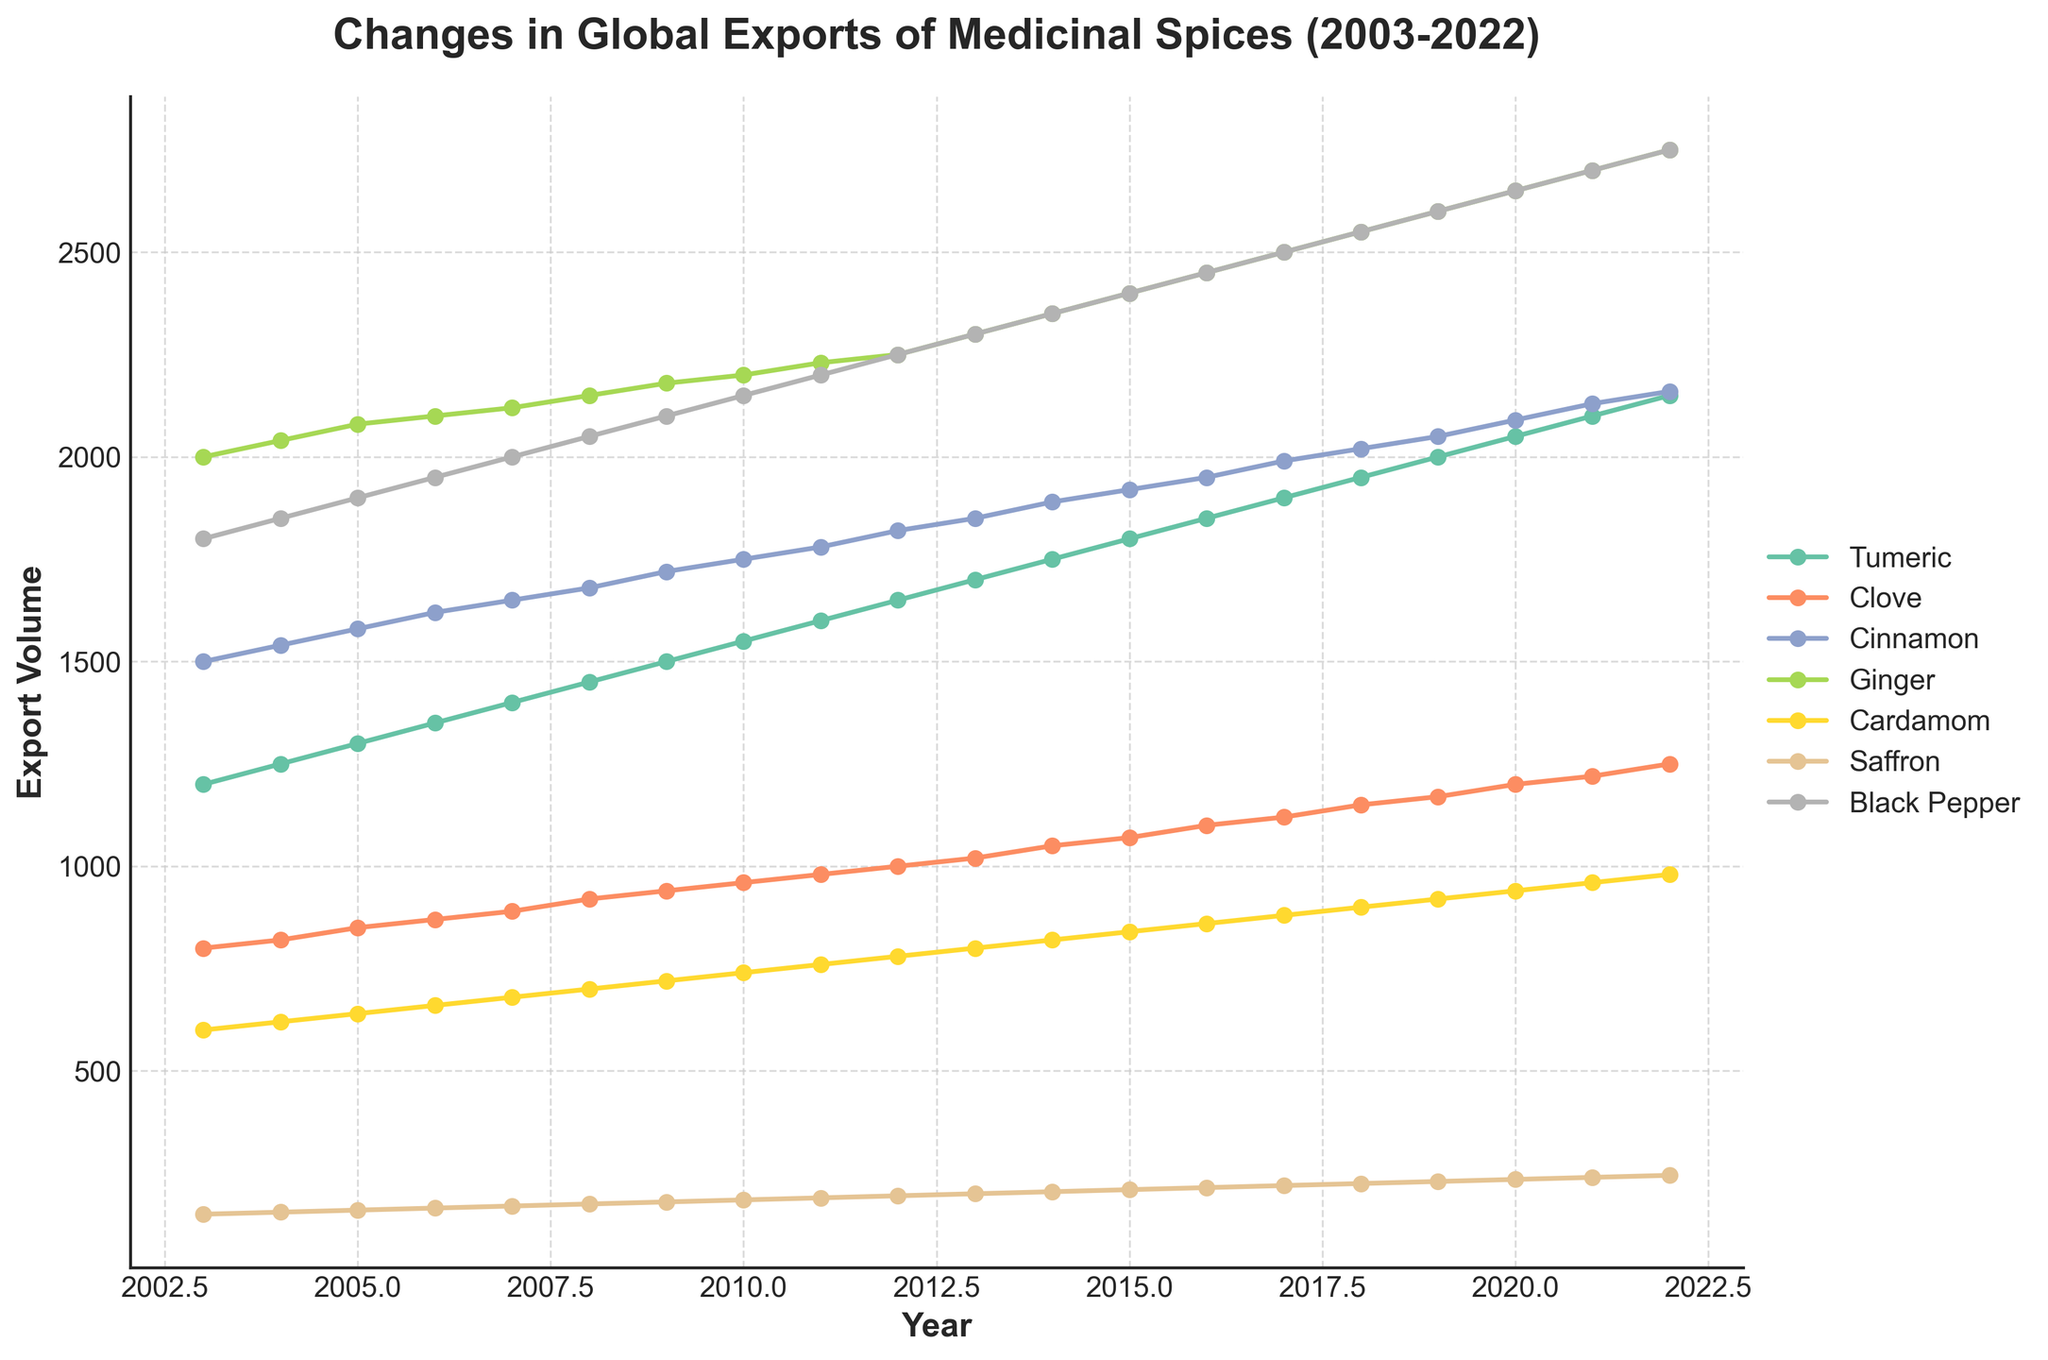What is the overall title of the plot? The title of a plot is typically found at the top, summarizing what the plot represents. In this case, the title is "Changes in Global Exports of Medicinal Spices (2003-2022)".
Answer: Changes in Global Exports of Medicinal Spices (2003-2022) What is the color used to represent Clove exports? The color representing Clove exports can be identified by the color-coded legend on the right side of the plot. According to the legend, Clove is represented by the second color in the colormap which is used consistently in the time series plot.
Answer: Light blue (typically) Which spice had the highest exports in 2003? Find the year 2003 on the x-axis and then look upwards to see which line is the highest at that point. The black pepper line is the topmost point, indicating the highest exports.
Answer: Black Pepper How has Tumeric exports changed from 2003 to 2022? Locate the Tumeric line in the plot, starting at the point corresponding to 1200 in 2003 and ending at 2150 in 2022. The export volume has shown a consistent increase.
Answer: Increased Which spice had the least export volume in 2022? Find the year 2022 on the x-axis and examine the positions of all the spice lines. The Saffron line is the lowest at that point in the plot.
Answer: Saffron By how much did Ginger exports increase from 2010 to 2022? Identify the export volumes of Ginger in 2010 and 2022 by looking at the corresponding points on the plot. Ginger exports were 2200 in 2010 and 2750 in 2022. The increase is calculated as 2750 - 2200.
Answer: 550 Which two spices showed a similar trend in export volumes over the years? Look at the overall trends of the lines on the plot, focusing on their shape and trajectory over the years. For example, Clove and Cinnamon have similar trends as both lines follow almost parallel paths.
Answer: Clove and Cinnamon Did any spice show a decrease in exports at any point during the plotted period? To check for a decrease, identify if any line dips or declines at any portion of the plot. None of the lines show a decreasing trend over the plotted years.
Answer: No, all showed an increase In which year did Cardamom exports first exceed 800? Identify the point where the Cardamom line first crosses the 800 mark on the export volume (y-axis). This occurs in the year between 2006 and 2007.
Answer: 2007 How does the export volume of Saffron in 2022 compare to that in 2013? Look up the Saffron points for the years 2022 and 2013. The volumes are 245 in 2022 and 200 in 2013. Saffron exports increased from 2013 to 2022.
Answer: Increased 